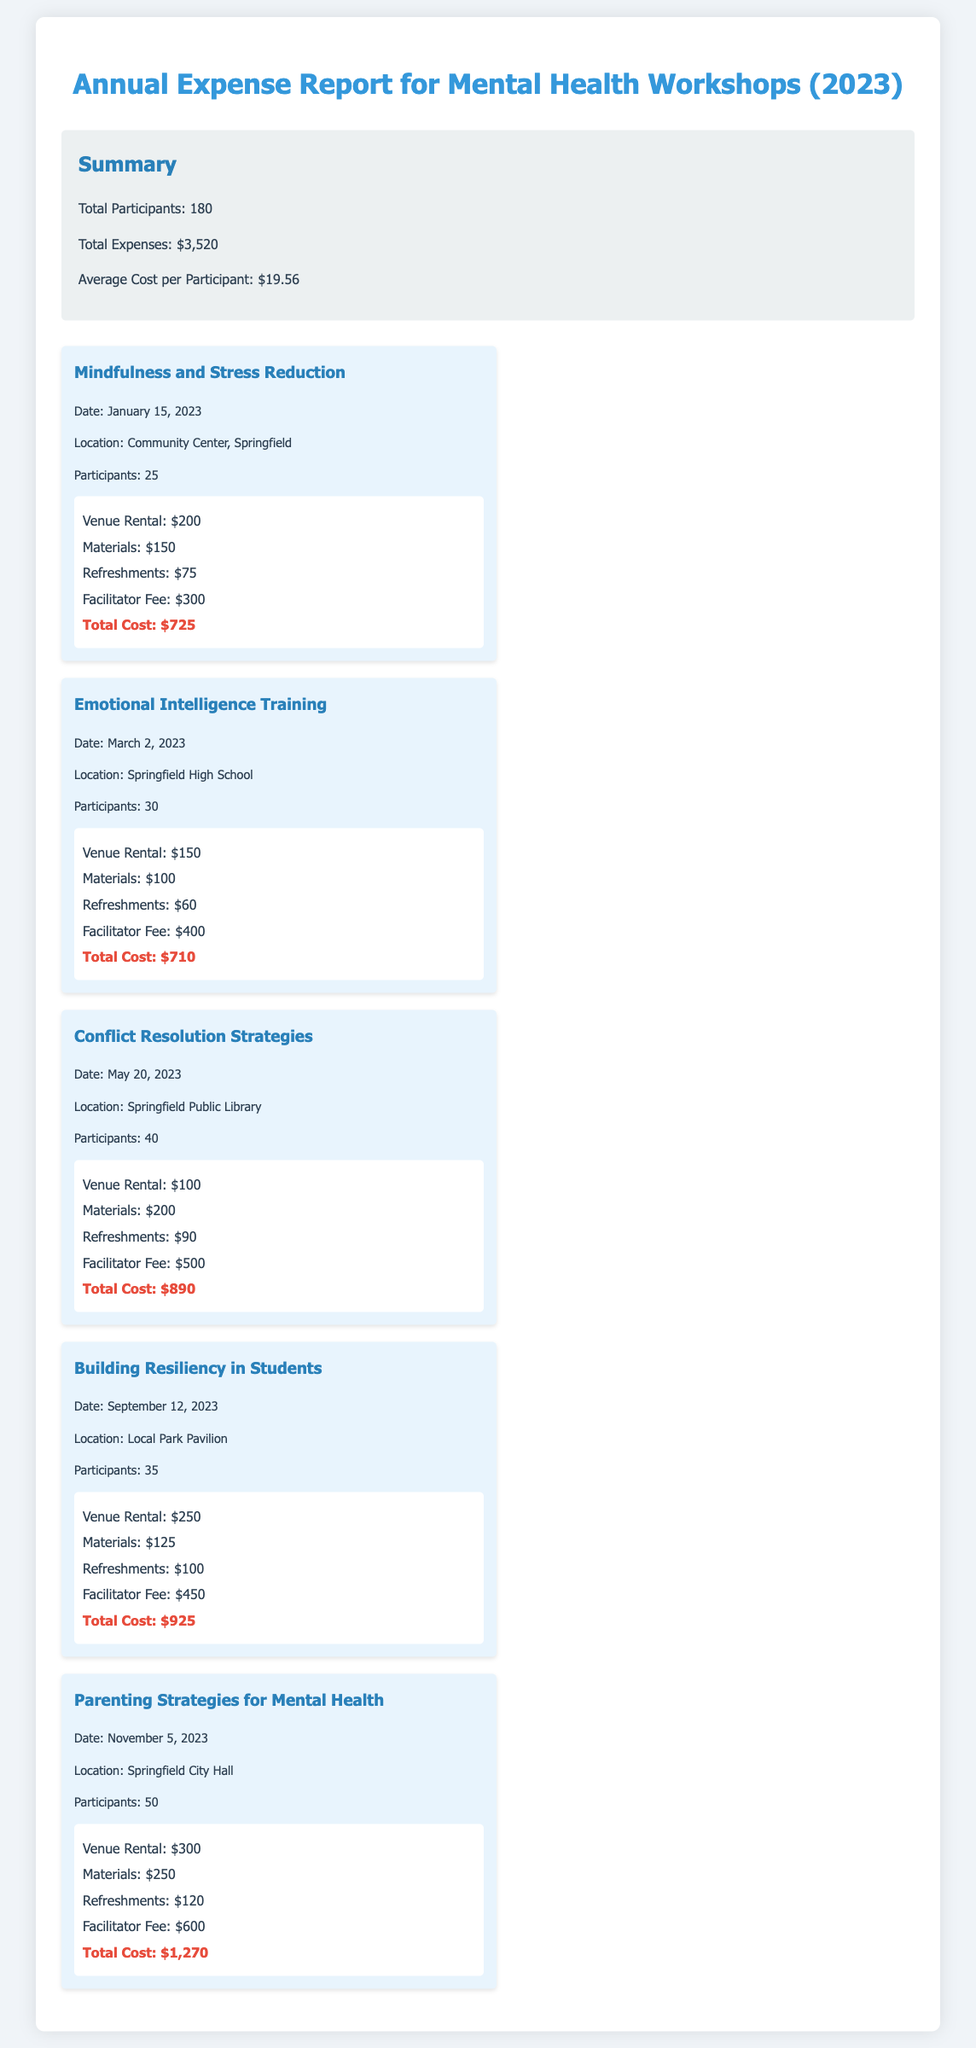What is the total number of participants? The document states that the total number of participants across all workshops is 180.
Answer: 180 What is the total expense for the workshops? The total expenses for all workshops conducted throughout the year is listed as $3,520.
Answer: $3,520 How much did the "Mindfulness and Stress Reduction" workshop cost? The cost for the "Mindfulness and Stress Reduction" workshop is detailed as $725.
Answer: $725 What was the participant count for the "Parenting Strategies for Mental Health" workshop? The document notes that there were 50 participants in the "Parenting Strategies for Mental Health" workshop.
Answer: 50 Which workshop had the highest expense? The highest expense is for the "Parenting Strategies for Mental Health" workshop, totaling $1,270.
Answer: Parenting Strategies for Mental Health What is the average cost per participant? The average cost per participant is calculated in the report as $19.56.
Answer: $19.56 How many workshops were conducted in 2023? The report outlines a total of five workshops conducted throughout the year.
Answer: 5 What is the venue for the "Building Resiliency in Students" workshop? The document lists the location of the "Building Resiliency in Students" workshop as the Local Park Pavilion.
Answer: Local Park Pavilion What was the date of the "Emotional Intelligence Training" workshop? The date noted for the "Emotional Intelligence Training" workshop is March 2, 2023.
Answer: March 2, 2023 